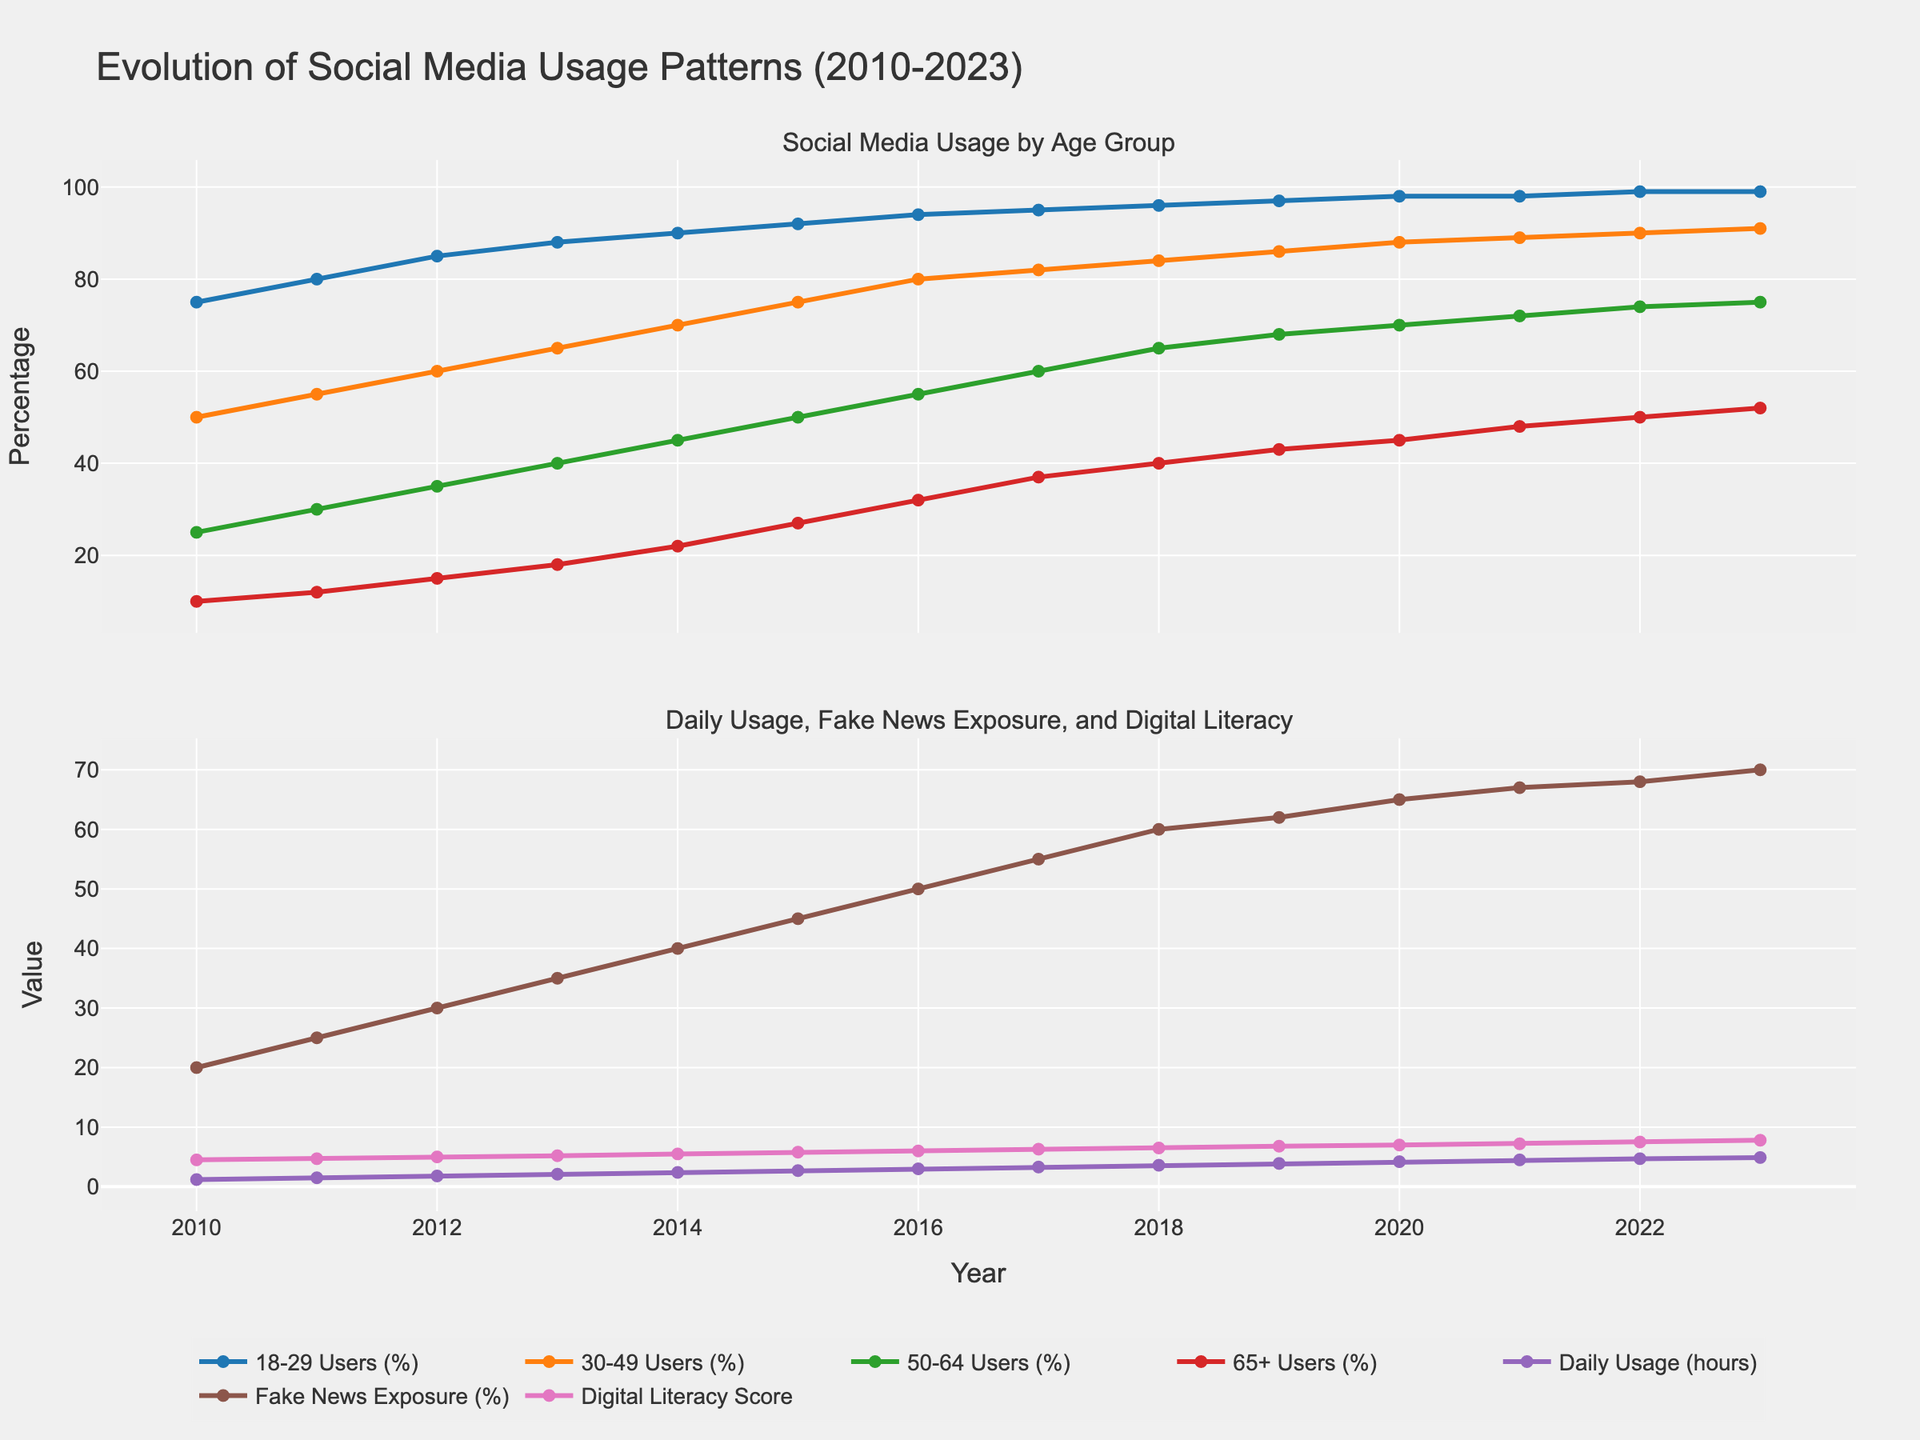What is the trend in social media usage for the 65+ age group from 2010 to 2023? The 65+ age group shows an increasing trend in social media usage over the years. Starting from 10% in 2010, it progressively rises each year, reaching 52% in 2023. This shows a notable growth pattern among older adults.
Answer: Increasing How does the digital literacy score change from 2010 to 2023? The digital literacy score shows a steady upward trend. It starts at 4.5 in 2010 and gradually increases each year, finally reaching 7.8 in 2023. The consistent rise indicates improvement in digital literacy over the years.
Answer: Increasing Compare the daily usage hours between 2010 and 2023. In 2010, the daily usage was 1.2 hours. By 2023, this has increased to 4.9 hours. Therefore, daily usage has significantly increased over the period.
Answer: 1.2 hours in 2010, 4.9 hours in 2023 Which age group has the highest social media usage in 2023? The 18-29 age group has the highest social media usage in 2023, with a user percentage of 99%.
Answer: 18-29 What is the difference in fake news exposure between 2010 and 2023? In 2010, fake news exposure was 20%. By 2023, it increased to 70%. Therefore, the difference is 70% - 20% = 50%.
Answer: 50% What is the pattern of fake news exposure over the years? Fake news exposure shows a clear upward trend, starting at 20% in 2010 and gradually increasing to 70% in 2023.
Answer: Increasing Which year shows the maximum yearly increase in social media usage for the 50-64 age group? By analyzing the data, the greatest yearly increase for the 50-64 age group happens between 2015 (50%) and 2016 (55%), which is a 5% increase.
Answer: 2015 to 2016 Between 18-29 Users and 30-49 Users, which group had more usage in 2015, and by how much? In 2015, 18-29 Users had 92% usage, and 30-49 Users had 75% usage. The difference is 92% - 75% = 17%.
Answer: 18-29 Users by 17% How has daily usage changed as digital literacy scores increased? Both daily usage and digital literacy scores show upward trends from 2010 to 2023. Daily usage hours increased from 1.2 to 4.9, while digital literacy scores increased from 4.5 to 7.8.
Answer: Both increased On average, how much did social media usage increase across all age groups from 2010 to 2023? Across all age groups (18-29, 30-49, 50-64, 65+), the social media usage increased from (75%+50%+25%+10%) = 160% in 2010 to (99%+91%+75%+52%) = 317% in 2023. The average increase per group is 317/4 - 160/4 = 157/4 = 39.25%.
Answer: 39.25% 